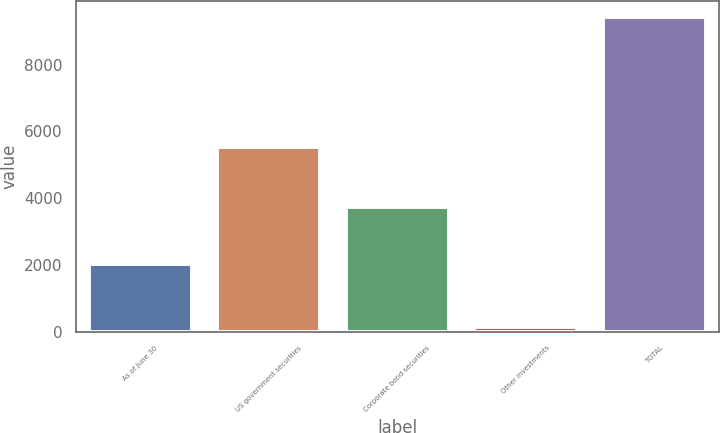<chart> <loc_0><loc_0><loc_500><loc_500><bar_chart><fcel>As of June 30<fcel>US government securities<fcel>Corporate bond securities<fcel>Other investments<fcel>TOTAL<nl><fcel>2018<fcel>5544<fcel>3737<fcel>141<fcel>9422<nl></chart> 